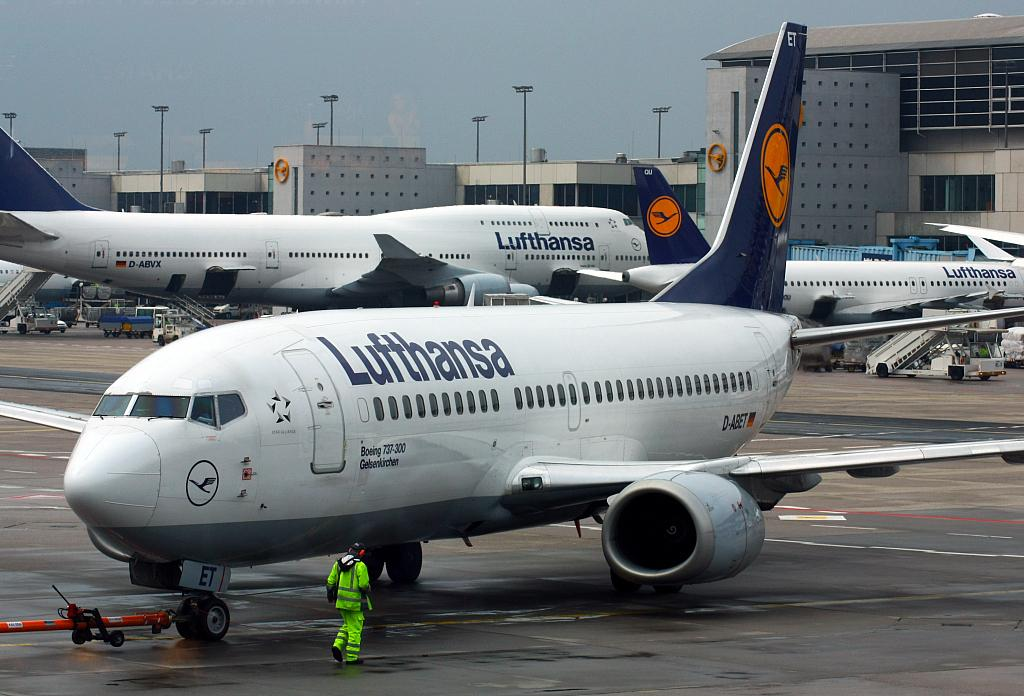<image>
Offer a succinct explanation of the picture presented. Lufthansa aircraft sits on the tarmac with three other planes 